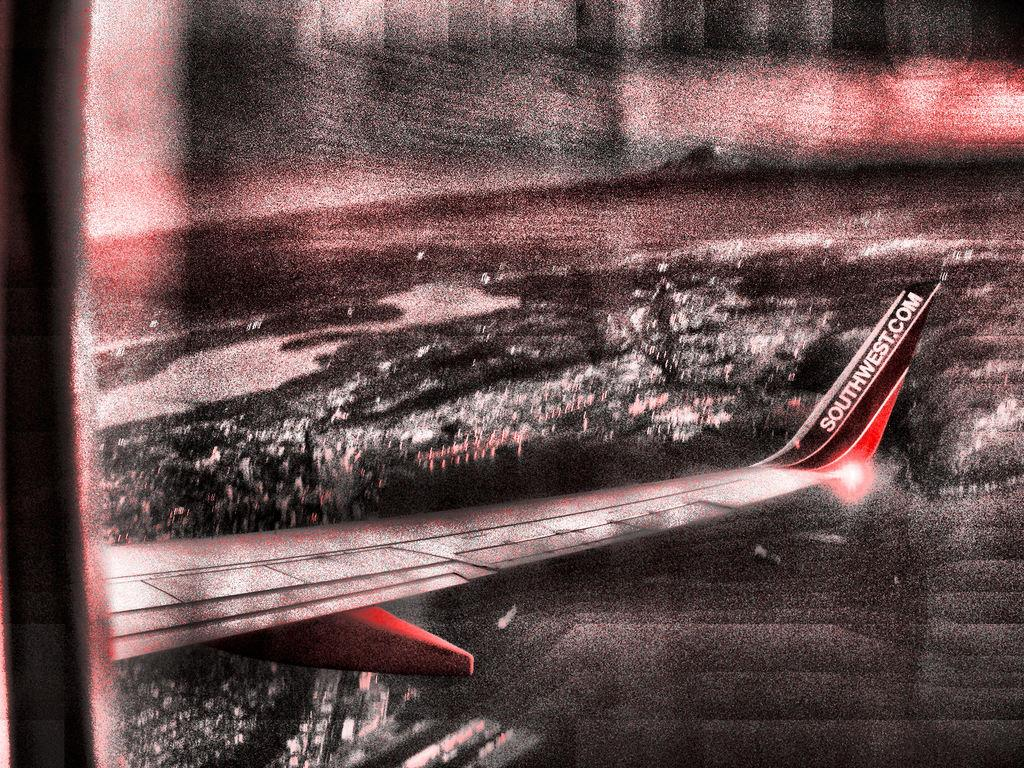<image>
Summarize the visual content of the image. The right wing of a Southwest airplane is seen above a lit city. 